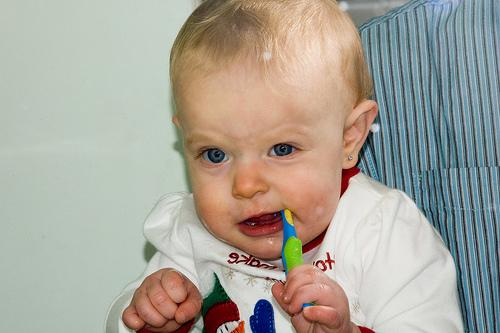Please describe the appearance of the baby in the image. The baby has blonde hair, blue eyes, pierced ear, and is wearing a mostly-white smock. Mention the main activity and any other object in the baby's mouth. The baby is brushing its teeth, and there is a blue, yellow, and green object in the mouth. Please describe the background color and another object found in the background of the image. The background has a white wall, and there's a blue-striped shirt behind the baby. What is notable about the baby's hands and what the baby is holding? The baby has two hands with fingers curled, holding a toothbrush in the mouth and a toy in the left hand. Mention the key features of the child's face in the picture. The child has blue eyes, an open mouth, a nose with two nostrils, and light brown hair on the head. What is the primary focus of the photo and the color of the baby's eyes? The primary focus is a baby brushing its teeth, and the baby has blue eyes. Identify the baby's piercing and the shirt behind the baby in the photo. The baby's ear is pierced, and there is a blue-striped shirt behind the baby. What is the primary activity of the child in the picture? The baby is brushing its teeth with a toothbrush in its mouth. Describe the color and pattern of the objects near the baby in the image. There is a white wall, a cover with blue stripes, a blue, yellow, and green object in the mouth, and red writing on a white cloth. What can be observed about the baby's ears and the clothing they are wearing? The baby's left ear is pierced with an earring, and the baby is wearing a mostly-white smock. 